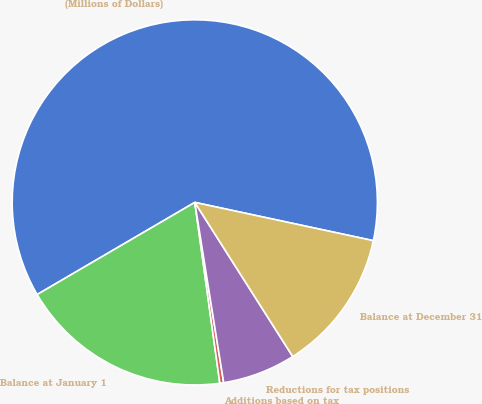Convert chart. <chart><loc_0><loc_0><loc_500><loc_500><pie_chart><fcel>(Millions of Dollars)<fcel>Balance at January 1<fcel>Additions based on tax<fcel>Reductions for tax positions<fcel>Balance at December 31<nl><fcel>61.78%<fcel>18.77%<fcel>0.34%<fcel>6.48%<fcel>12.63%<nl></chart> 